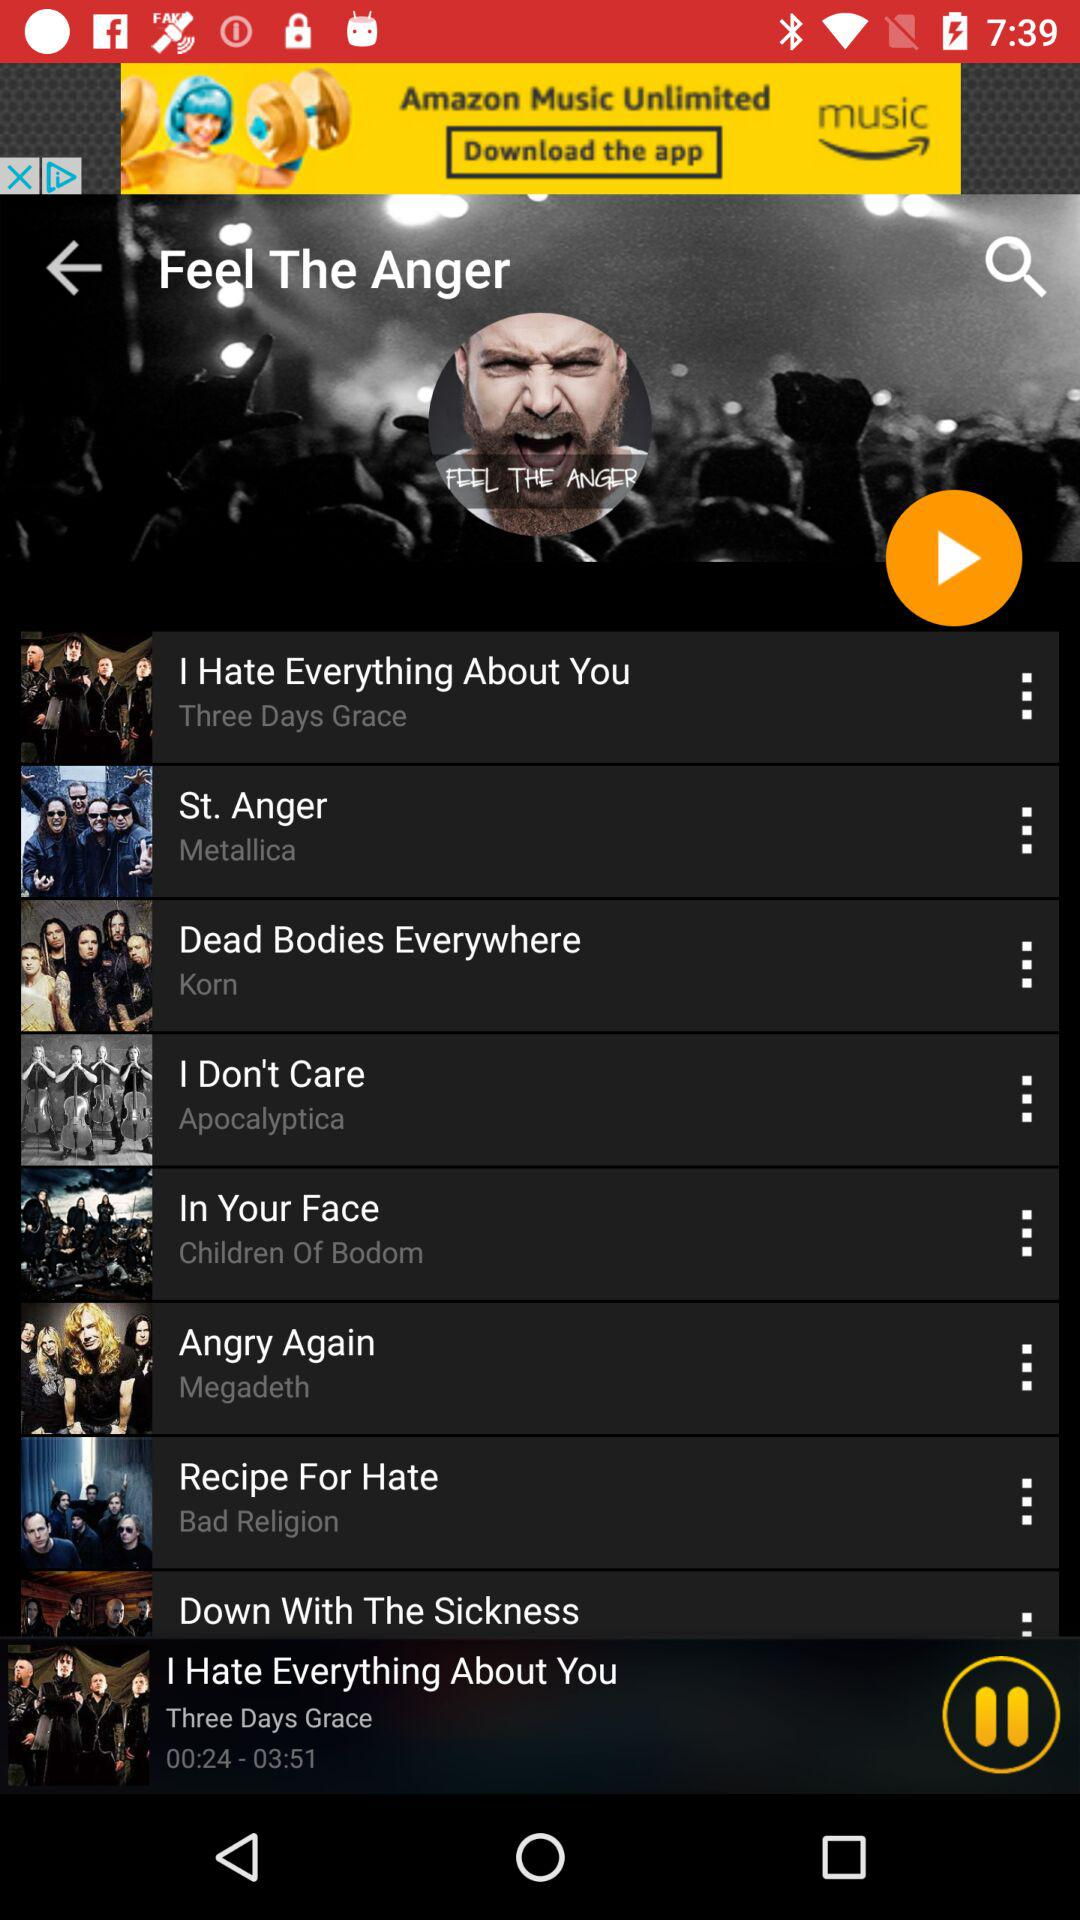Which song is playing? The song that is playing is "I Hate Everything About You". 